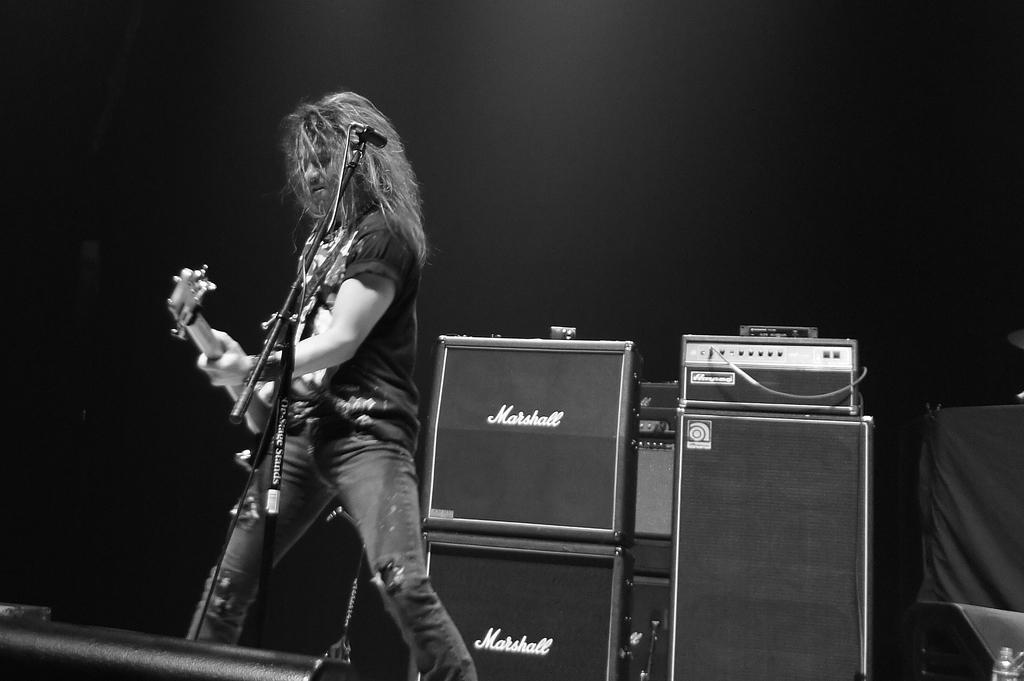<image>
Provide a brief description of the given image. the word marshall is on one of the speakers 